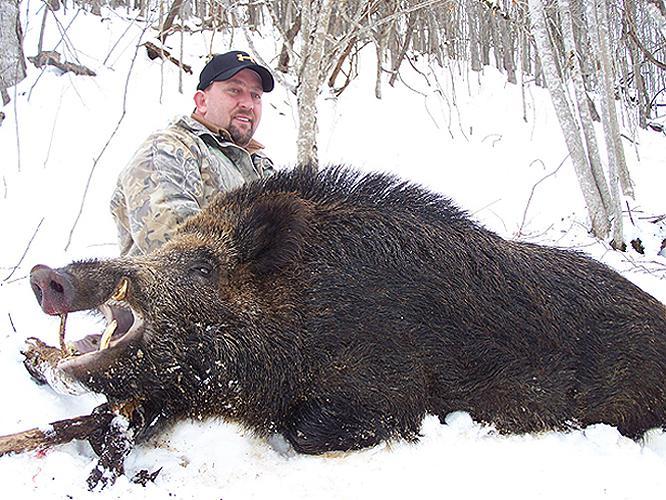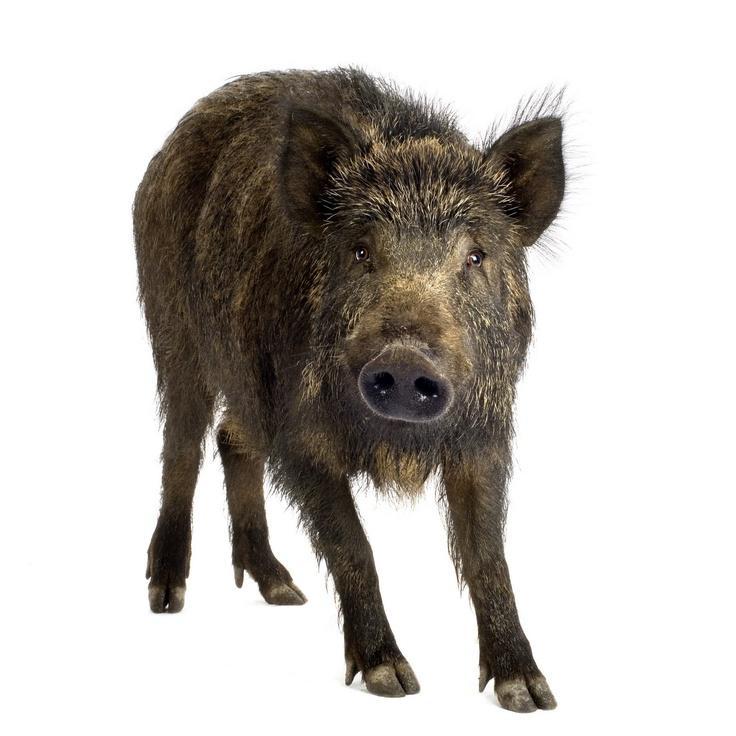The first image is the image on the left, the second image is the image on the right. Analyze the images presented: Is the assertion "A single wild pig is in the snow in each of the images." valid? Answer yes or no. Yes. 